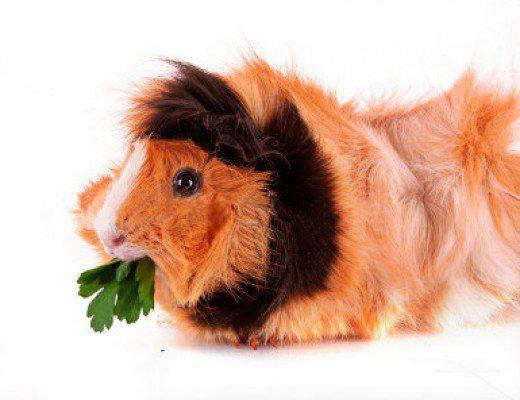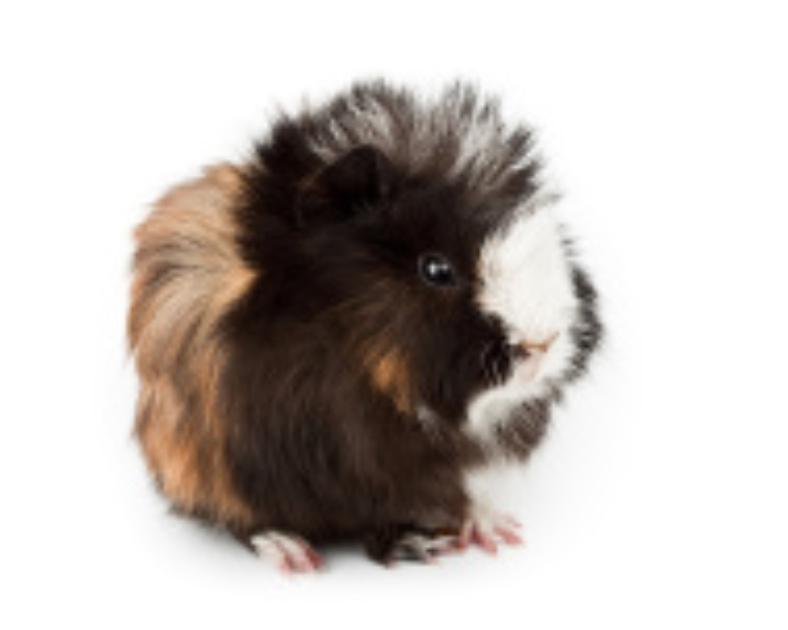The first image is the image on the left, the second image is the image on the right. Examine the images to the left and right. Is the description "Each image contains a single guinea pig, and the one on the right has all golden-orange fur." accurate? Answer yes or no. No. 